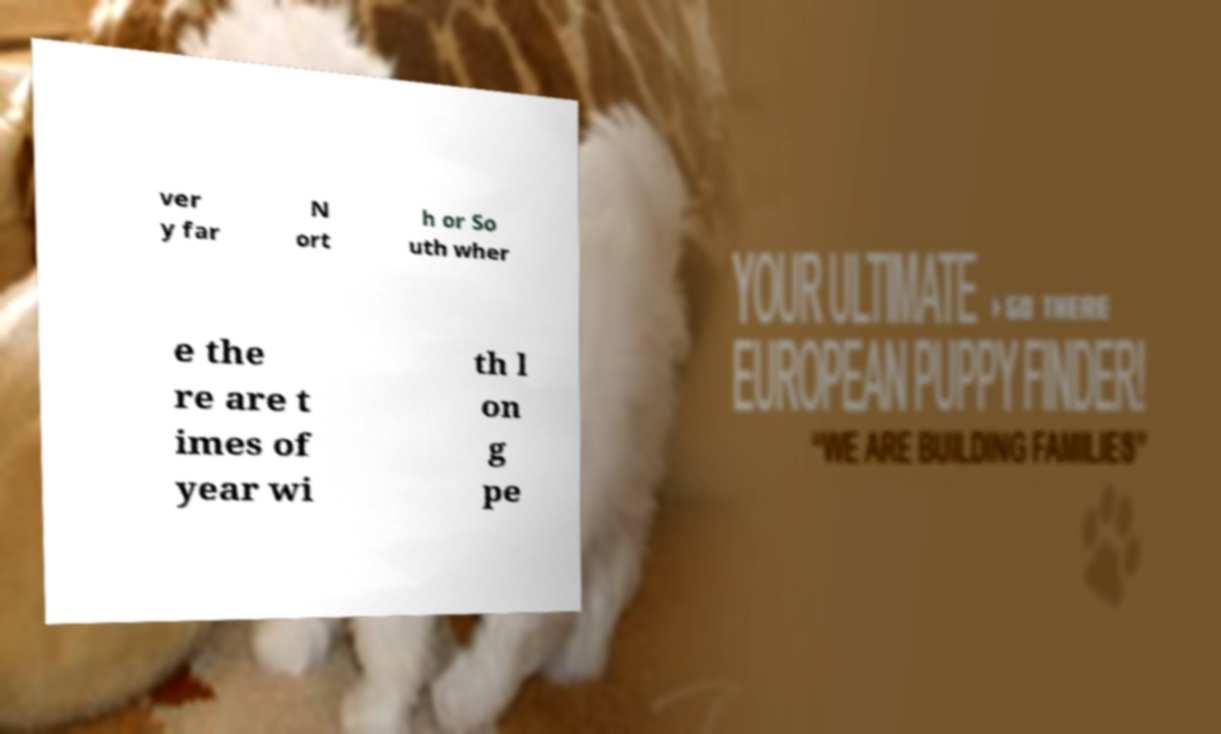Could you extract and type out the text from this image? ver y far N ort h or So uth wher e the re are t imes of year wi th l on g pe 